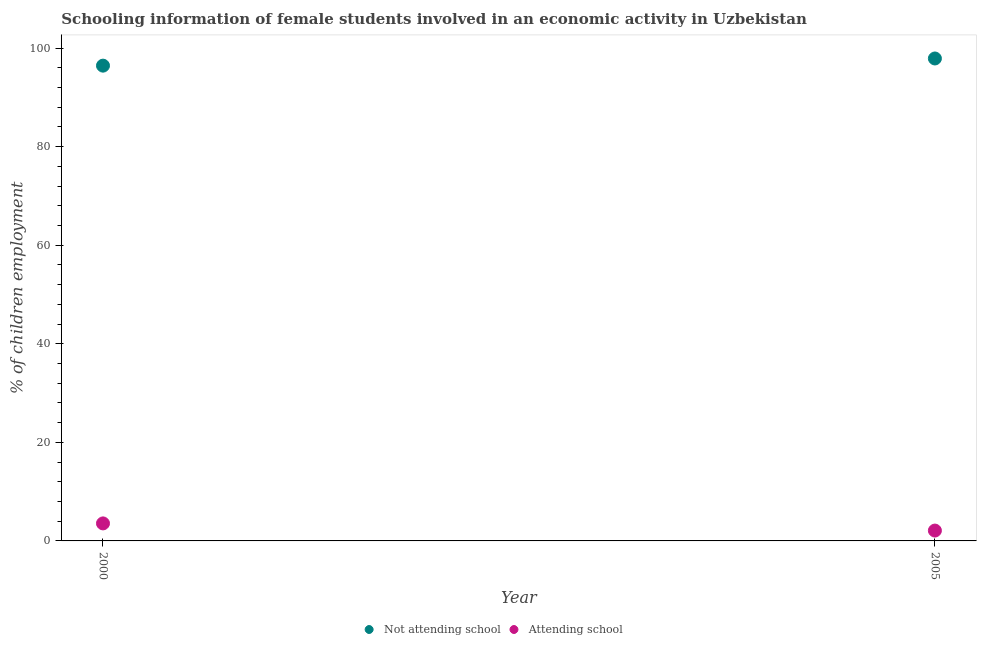Is the number of dotlines equal to the number of legend labels?
Provide a short and direct response. Yes. What is the percentage of employed females who are not attending school in 2000?
Provide a succinct answer. 96.45. Across all years, what is the maximum percentage of employed females who are attending school?
Ensure brevity in your answer.  3.55. Across all years, what is the minimum percentage of employed females who are attending school?
Your response must be concise. 2.1. In which year was the percentage of employed females who are not attending school minimum?
Make the answer very short. 2000. What is the total percentage of employed females who are not attending school in the graph?
Provide a short and direct response. 194.35. What is the difference between the percentage of employed females who are not attending school in 2000 and that in 2005?
Make the answer very short. -1.45. What is the difference between the percentage of employed females who are attending school in 2000 and the percentage of employed females who are not attending school in 2005?
Offer a terse response. -94.35. What is the average percentage of employed females who are not attending school per year?
Your answer should be very brief. 97.17. In the year 2000, what is the difference between the percentage of employed females who are attending school and percentage of employed females who are not attending school?
Give a very brief answer. -92.89. In how many years, is the percentage of employed females who are not attending school greater than 24 %?
Give a very brief answer. 2. What is the ratio of the percentage of employed females who are not attending school in 2000 to that in 2005?
Give a very brief answer. 0.99. Does the percentage of employed females who are not attending school monotonically increase over the years?
Your answer should be compact. Yes. Is the percentage of employed females who are attending school strictly greater than the percentage of employed females who are not attending school over the years?
Ensure brevity in your answer.  No. Is the percentage of employed females who are not attending school strictly less than the percentage of employed females who are attending school over the years?
Make the answer very short. No. How many dotlines are there?
Make the answer very short. 2. How many years are there in the graph?
Provide a succinct answer. 2. What is the difference between two consecutive major ticks on the Y-axis?
Make the answer very short. 20. Does the graph contain grids?
Your answer should be very brief. No. How are the legend labels stacked?
Make the answer very short. Horizontal. What is the title of the graph?
Your answer should be very brief. Schooling information of female students involved in an economic activity in Uzbekistan. Does "Food and tobacco" appear as one of the legend labels in the graph?
Keep it short and to the point. No. What is the label or title of the Y-axis?
Your answer should be very brief. % of children employment. What is the % of children employment in Not attending school in 2000?
Your response must be concise. 96.45. What is the % of children employment in Attending school in 2000?
Your answer should be compact. 3.55. What is the % of children employment of Not attending school in 2005?
Ensure brevity in your answer.  97.9. What is the % of children employment of Attending school in 2005?
Your answer should be very brief. 2.1. Across all years, what is the maximum % of children employment in Not attending school?
Offer a very short reply. 97.9. Across all years, what is the maximum % of children employment of Attending school?
Your answer should be very brief. 3.55. Across all years, what is the minimum % of children employment of Not attending school?
Offer a terse response. 96.45. What is the total % of children employment of Not attending school in the graph?
Keep it short and to the point. 194.35. What is the total % of children employment of Attending school in the graph?
Provide a succinct answer. 5.65. What is the difference between the % of children employment of Not attending school in 2000 and that in 2005?
Your answer should be compact. -1.45. What is the difference between the % of children employment in Attending school in 2000 and that in 2005?
Your answer should be compact. 1.45. What is the difference between the % of children employment of Not attending school in 2000 and the % of children employment of Attending school in 2005?
Your answer should be very brief. 94.35. What is the average % of children employment in Not attending school per year?
Give a very brief answer. 97.17. What is the average % of children employment of Attending school per year?
Your response must be concise. 2.83. In the year 2000, what is the difference between the % of children employment in Not attending school and % of children employment in Attending school?
Provide a succinct answer. 92.89. In the year 2005, what is the difference between the % of children employment in Not attending school and % of children employment in Attending school?
Offer a very short reply. 95.8. What is the ratio of the % of children employment of Not attending school in 2000 to that in 2005?
Your response must be concise. 0.99. What is the ratio of the % of children employment in Attending school in 2000 to that in 2005?
Ensure brevity in your answer.  1.69. What is the difference between the highest and the second highest % of children employment in Not attending school?
Ensure brevity in your answer.  1.45. What is the difference between the highest and the second highest % of children employment in Attending school?
Offer a very short reply. 1.45. What is the difference between the highest and the lowest % of children employment of Not attending school?
Give a very brief answer. 1.45. What is the difference between the highest and the lowest % of children employment in Attending school?
Offer a terse response. 1.45. 